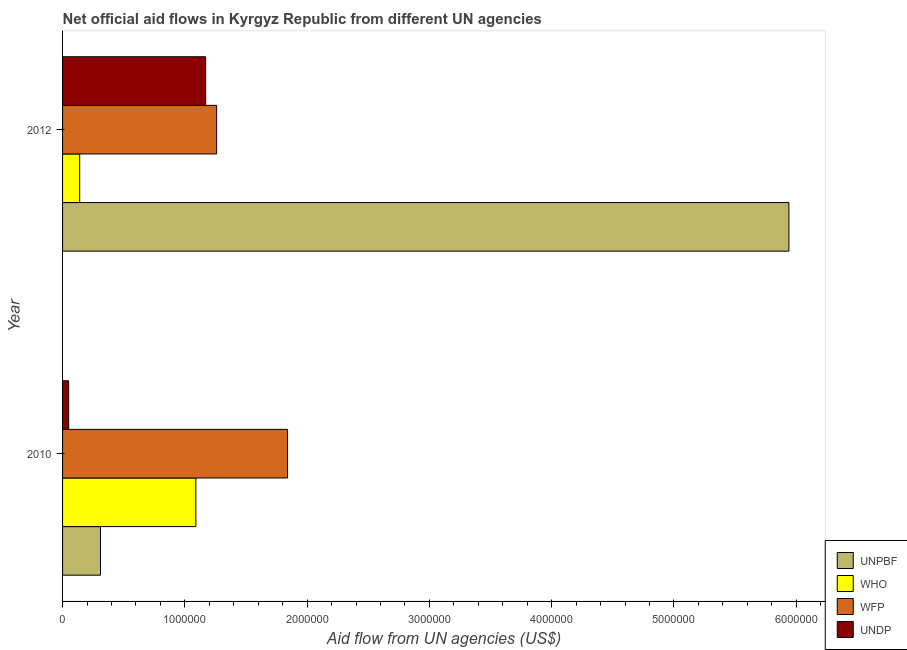How many different coloured bars are there?
Offer a very short reply. 4. Are the number of bars per tick equal to the number of legend labels?
Your answer should be very brief. Yes. Are the number of bars on each tick of the Y-axis equal?
Offer a very short reply. Yes. How many bars are there on the 1st tick from the top?
Provide a succinct answer. 4. What is the amount of aid given by undp in 2012?
Your response must be concise. 1.17e+06. Across all years, what is the maximum amount of aid given by who?
Ensure brevity in your answer.  1.09e+06. Across all years, what is the minimum amount of aid given by wfp?
Give a very brief answer. 1.26e+06. In which year was the amount of aid given by who minimum?
Offer a very short reply. 2012. What is the total amount of aid given by unpbf in the graph?
Offer a terse response. 6.25e+06. What is the difference between the amount of aid given by unpbf in 2010 and that in 2012?
Your answer should be compact. -5.63e+06. What is the difference between the amount of aid given by who in 2010 and the amount of aid given by undp in 2012?
Your answer should be very brief. -8.00e+04. What is the average amount of aid given by unpbf per year?
Give a very brief answer. 3.12e+06. In the year 2010, what is the difference between the amount of aid given by unpbf and amount of aid given by who?
Your response must be concise. -7.80e+05. What is the ratio of the amount of aid given by unpbf in 2010 to that in 2012?
Provide a short and direct response. 0.05. Is the difference between the amount of aid given by unpbf in 2010 and 2012 greater than the difference between the amount of aid given by undp in 2010 and 2012?
Provide a short and direct response. No. What does the 3rd bar from the top in 2010 represents?
Provide a succinct answer. WHO. What does the 4th bar from the bottom in 2012 represents?
Provide a short and direct response. UNDP. Is it the case that in every year, the sum of the amount of aid given by unpbf and amount of aid given by who is greater than the amount of aid given by wfp?
Keep it short and to the point. No. Are all the bars in the graph horizontal?
Your answer should be very brief. Yes. How many years are there in the graph?
Provide a short and direct response. 2. What is the difference between two consecutive major ticks on the X-axis?
Provide a short and direct response. 1.00e+06. Does the graph contain any zero values?
Your answer should be very brief. No. Does the graph contain grids?
Your answer should be very brief. No. Where does the legend appear in the graph?
Your answer should be compact. Bottom right. What is the title of the graph?
Provide a short and direct response. Net official aid flows in Kyrgyz Republic from different UN agencies. Does "Secondary general education" appear as one of the legend labels in the graph?
Offer a very short reply. No. What is the label or title of the X-axis?
Offer a terse response. Aid flow from UN agencies (US$). What is the Aid flow from UN agencies (US$) in UNPBF in 2010?
Your answer should be compact. 3.10e+05. What is the Aid flow from UN agencies (US$) in WHO in 2010?
Keep it short and to the point. 1.09e+06. What is the Aid flow from UN agencies (US$) of WFP in 2010?
Offer a very short reply. 1.84e+06. What is the Aid flow from UN agencies (US$) of UNDP in 2010?
Ensure brevity in your answer.  5.00e+04. What is the Aid flow from UN agencies (US$) of UNPBF in 2012?
Offer a very short reply. 5.94e+06. What is the Aid flow from UN agencies (US$) in WFP in 2012?
Make the answer very short. 1.26e+06. What is the Aid flow from UN agencies (US$) in UNDP in 2012?
Your response must be concise. 1.17e+06. Across all years, what is the maximum Aid flow from UN agencies (US$) in UNPBF?
Give a very brief answer. 5.94e+06. Across all years, what is the maximum Aid flow from UN agencies (US$) of WHO?
Your response must be concise. 1.09e+06. Across all years, what is the maximum Aid flow from UN agencies (US$) in WFP?
Give a very brief answer. 1.84e+06. Across all years, what is the maximum Aid flow from UN agencies (US$) of UNDP?
Provide a succinct answer. 1.17e+06. Across all years, what is the minimum Aid flow from UN agencies (US$) of WHO?
Ensure brevity in your answer.  1.40e+05. Across all years, what is the minimum Aid flow from UN agencies (US$) in WFP?
Offer a very short reply. 1.26e+06. Across all years, what is the minimum Aid flow from UN agencies (US$) of UNDP?
Ensure brevity in your answer.  5.00e+04. What is the total Aid flow from UN agencies (US$) of UNPBF in the graph?
Give a very brief answer. 6.25e+06. What is the total Aid flow from UN agencies (US$) in WHO in the graph?
Provide a short and direct response. 1.23e+06. What is the total Aid flow from UN agencies (US$) of WFP in the graph?
Your answer should be very brief. 3.10e+06. What is the total Aid flow from UN agencies (US$) of UNDP in the graph?
Provide a succinct answer. 1.22e+06. What is the difference between the Aid flow from UN agencies (US$) of UNPBF in 2010 and that in 2012?
Your answer should be compact. -5.63e+06. What is the difference between the Aid flow from UN agencies (US$) in WHO in 2010 and that in 2012?
Provide a short and direct response. 9.50e+05. What is the difference between the Aid flow from UN agencies (US$) of WFP in 2010 and that in 2012?
Your answer should be very brief. 5.80e+05. What is the difference between the Aid flow from UN agencies (US$) in UNDP in 2010 and that in 2012?
Give a very brief answer. -1.12e+06. What is the difference between the Aid flow from UN agencies (US$) of UNPBF in 2010 and the Aid flow from UN agencies (US$) of WFP in 2012?
Your response must be concise. -9.50e+05. What is the difference between the Aid flow from UN agencies (US$) in UNPBF in 2010 and the Aid flow from UN agencies (US$) in UNDP in 2012?
Ensure brevity in your answer.  -8.60e+05. What is the difference between the Aid flow from UN agencies (US$) of WHO in 2010 and the Aid flow from UN agencies (US$) of WFP in 2012?
Offer a terse response. -1.70e+05. What is the difference between the Aid flow from UN agencies (US$) of WFP in 2010 and the Aid flow from UN agencies (US$) of UNDP in 2012?
Make the answer very short. 6.70e+05. What is the average Aid flow from UN agencies (US$) of UNPBF per year?
Your response must be concise. 3.12e+06. What is the average Aid flow from UN agencies (US$) of WHO per year?
Offer a terse response. 6.15e+05. What is the average Aid flow from UN agencies (US$) of WFP per year?
Keep it short and to the point. 1.55e+06. What is the average Aid flow from UN agencies (US$) of UNDP per year?
Give a very brief answer. 6.10e+05. In the year 2010, what is the difference between the Aid flow from UN agencies (US$) of UNPBF and Aid flow from UN agencies (US$) of WHO?
Your answer should be compact. -7.80e+05. In the year 2010, what is the difference between the Aid flow from UN agencies (US$) in UNPBF and Aid flow from UN agencies (US$) in WFP?
Offer a terse response. -1.53e+06. In the year 2010, what is the difference between the Aid flow from UN agencies (US$) in UNPBF and Aid flow from UN agencies (US$) in UNDP?
Give a very brief answer. 2.60e+05. In the year 2010, what is the difference between the Aid flow from UN agencies (US$) in WHO and Aid flow from UN agencies (US$) in WFP?
Your answer should be compact. -7.50e+05. In the year 2010, what is the difference between the Aid flow from UN agencies (US$) in WHO and Aid flow from UN agencies (US$) in UNDP?
Give a very brief answer. 1.04e+06. In the year 2010, what is the difference between the Aid flow from UN agencies (US$) of WFP and Aid flow from UN agencies (US$) of UNDP?
Your answer should be very brief. 1.79e+06. In the year 2012, what is the difference between the Aid flow from UN agencies (US$) in UNPBF and Aid flow from UN agencies (US$) in WHO?
Your answer should be very brief. 5.80e+06. In the year 2012, what is the difference between the Aid flow from UN agencies (US$) in UNPBF and Aid flow from UN agencies (US$) in WFP?
Provide a short and direct response. 4.68e+06. In the year 2012, what is the difference between the Aid flow from UN agencies (US$) in UNPBF and Aid flow from UN agencies (US$) in UNDP?
Your answer should be compact. 4.77e+06. In the year 2012, what is the difference between the Aid flow from UN agencies (US$) in WHO and Aid flow from UN agencies (US$) in WFP?
Keep it short and to the point. -1.12e+06. In the year 2012, what is the difference between the Aid flow from UN agencies (US$) in WHO and Aid flow from UN agencies (US$) in UNDP?
Your answer should be very brief. -1.03e+06. What is the ratio of the Aid flow from UN agencies (US$) in UNPBF in 2010 to that in 2012?
Provide a short and direct response. 0.05. What is the ratio of the Aid flow from UN agencies (US$) of WHO in 2010 to that in 2012?
Make the answer very short. 7.79. What is the ratio of the Aid flow from UN agencies (US$) in WFP in 2010 to that in 2012?
Make the answer very short. 1.46. What is the ratio of the Aid flow from UN agencies (US$) in UNDP in 2010 to that in 2012?
Provide a succinct answer. 0.04. What is the difference between the highest and the second highest Aid flow from UN agencies (US$) in UNPBF?
Your response must be concise. 5.63e+06. What is the difference between the highest and the second highest Aid flow from UN agencies (US$) of WHO?
Provide a succinct answer. 9.50e+05. What is the difference between the highest and the second highest Aid flow from UN agencies (US$) of WFP?
Give a very brief answer. 5.80e+05. What is the difference between the highest and the second highest Aid flow from UN agencies (US$) of UNDP?
Offer a terse response. 1.12e+06. What is the difference between the highest and the lowest Aid flow from UN agencies (US$) of UNPBF?
Your answer should be compact. 5.63e+06. What is the difference between the highest and the lowest Aid flow from UN agencies (US$) in WHO?
Ensure brevity in your answer.  9.50e+05. What is the difference between the highest and the lowest Aid flow from UN agencies (US$) of WFP?
Ensure brevity in your answer.  5.80e+05. What is the difference between the highest and the lowest Aid flow from UN agencies (US$) in UNDP?
Ensure brevity in your answer.  1.12e+06. 